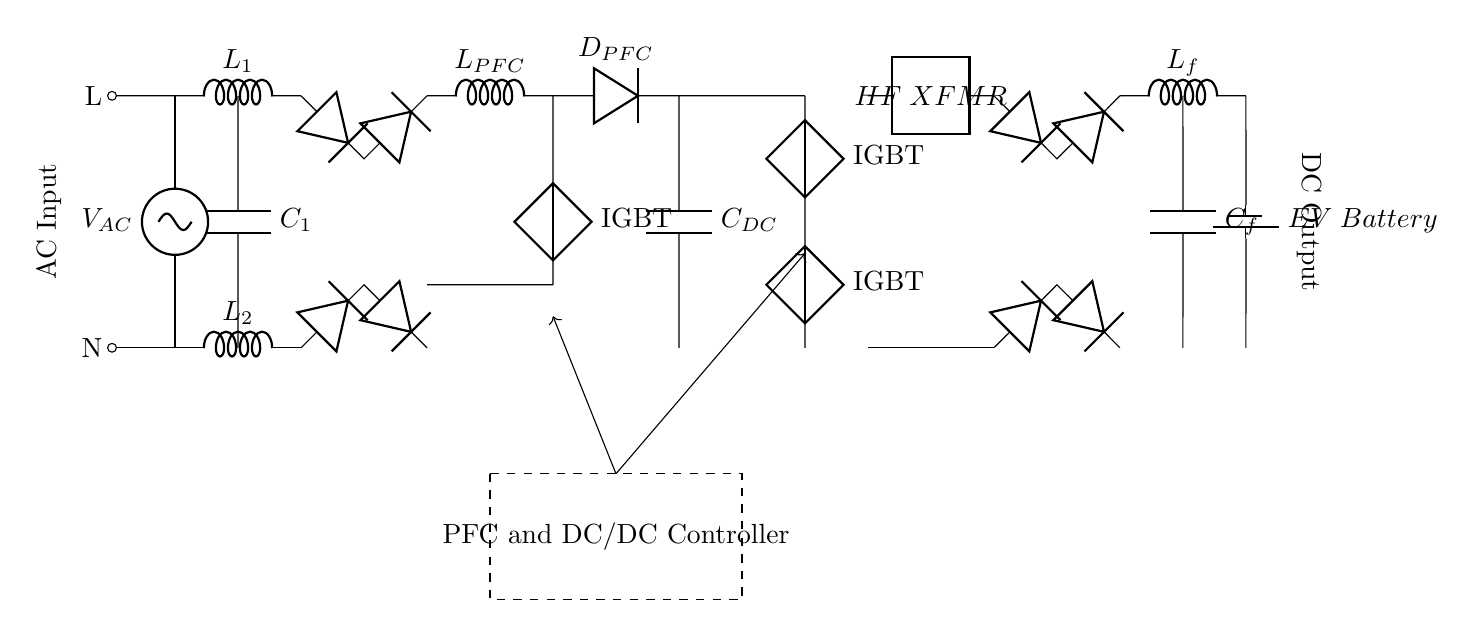What is the type of the input source in this circuit? The input source is an AC source, as indicated by the notation "V_AC" at the top left of the circuit diagram.
Answer: AC source What component provides power factor correction in this circuit? The inductor labeled "L_PFC" is responsible for power factor correction in this circuit, as it is part of the PFC Boost Converter section, which aims to improve the power factor of the input current.
Answer: L_PFC How many capacitors are present in the circuit? There are three capacitors in the circuit: "C_1" associated with the EMI filter, "C_DC" as the DC link capacitor, and "C_f" as the output filter capacitor.
Answer: 3 What is the role of the "HF XFMR" in the circuit? The "HF XFMR" (High Frequency Transformer) serves to isolate and step down or step up the voltage for efficient power transfer in high-frequency applications, crucial for the DC/DC conversion stage of the electrical vehicle charging process.
Answer: High Frequency Transformer What type of control circuitry is employed in this design? The circuit employs a "PFC and DC/DC Controller," which is shown in the dashed rectangle and is responsible for controlling both the power factor correction and the DC/DC conversion processes to ensure efficient charging of the EV battery.
Answer: PFC and DC/DC Controller What is the purpose of the bridge rectifier in this circuit? The bridge rectifier converts the AC voltage from the input source into a DC voltage, facilitating the subsequent stages that require DC power, such as the DC link capacitor and the boost converter.
Answer: Convert AC to DC 